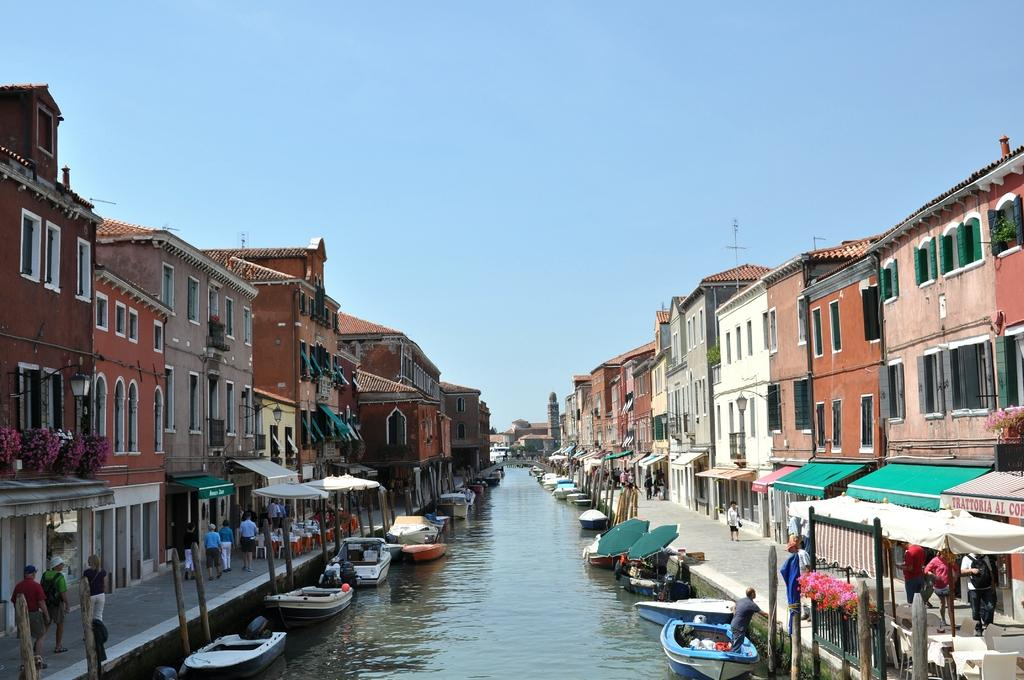Who or what can be seen in the image? There are people in the image. What is on the water in the image? There are boats on the water. What type of structures are present in the image? Wooden poles, chairs, tents, and buildings are visible in the image. What type of vegetation is in the image? Flowers are in the image. What is visible in the background of the image? The sky is visible in the background of the image. What type of riddle is being solved by the band in the image? There is no band present in the image, and therefore no riddle-solving activity can be observed. How fast are the people running in the image? There is no indication of anyone running in the image; the people are stationary. 